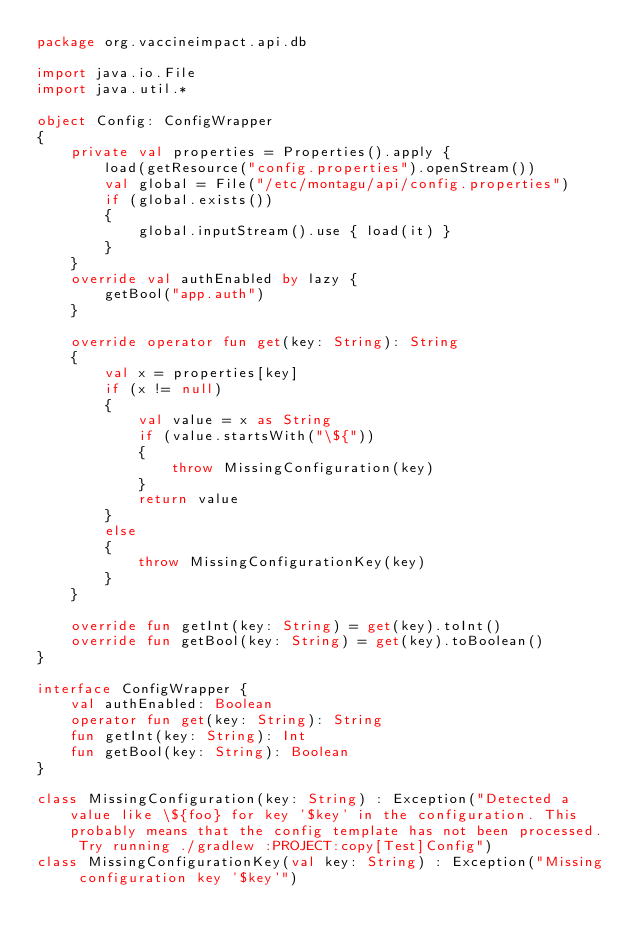Convert code to text. <code><loc_0><loc_0><loc_500><loc_500><_Kotlin_>package org.vaccineimpact.api.db

import java.io.File
import java.util.*

object Config: ConfigWrapper
{
    private val properties = Properties().apply {
        load(getResource("config.properties").openStream())
        val global = File("/etc/montagu/api/config.properties")
        if (global.exists())
        {
            global.inputStream().use { load(it) }
        }
    }
    override val authEnabled by lazy {
        getBool("app.auth")
    }

    override operator fun get(key: String): String
    {
        val x = properties[key]
        if (x != null)
        {
            val value = x as String
            if (value.startsWith("\${"))
            {
                throw MissingConfiguration(key)
            }
            return value
        }
        else
        {
            throw MissingConfigurationKey(key)
        }
    }

    override fun getInt(key: String) = get(key).toInt()
    override fun getBool(key: String) = get(key).toBoolean()
}

interface ConfigWrapper {
    val authEnabled: Boolean
    operator fun get(key: String): String
    fun getInt(key: String): Int
    fun getBool(key: String): Boolean
}

class MissingConfiguration(key: String) : Exception("Detected a value like \${foo} for key '$key' in the configuration. This probably means that the config template has not been processed. Try running ./gradlew :PROJECT:copy[Test]Config")
class MissingConfigurationKey(val key: String) : Exception("Missing configuration key '$key'")</code> 